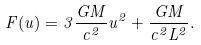Convert formula to latex. <formula><loc_0><loc_0><loc_500><loc_500>F ( u ) = 3 \frac { G M } { c ^ { 2 } } u ^ { 2 } + \frac { G M } { c ^ { 2 } L ^ { 2 } } .</formula> 